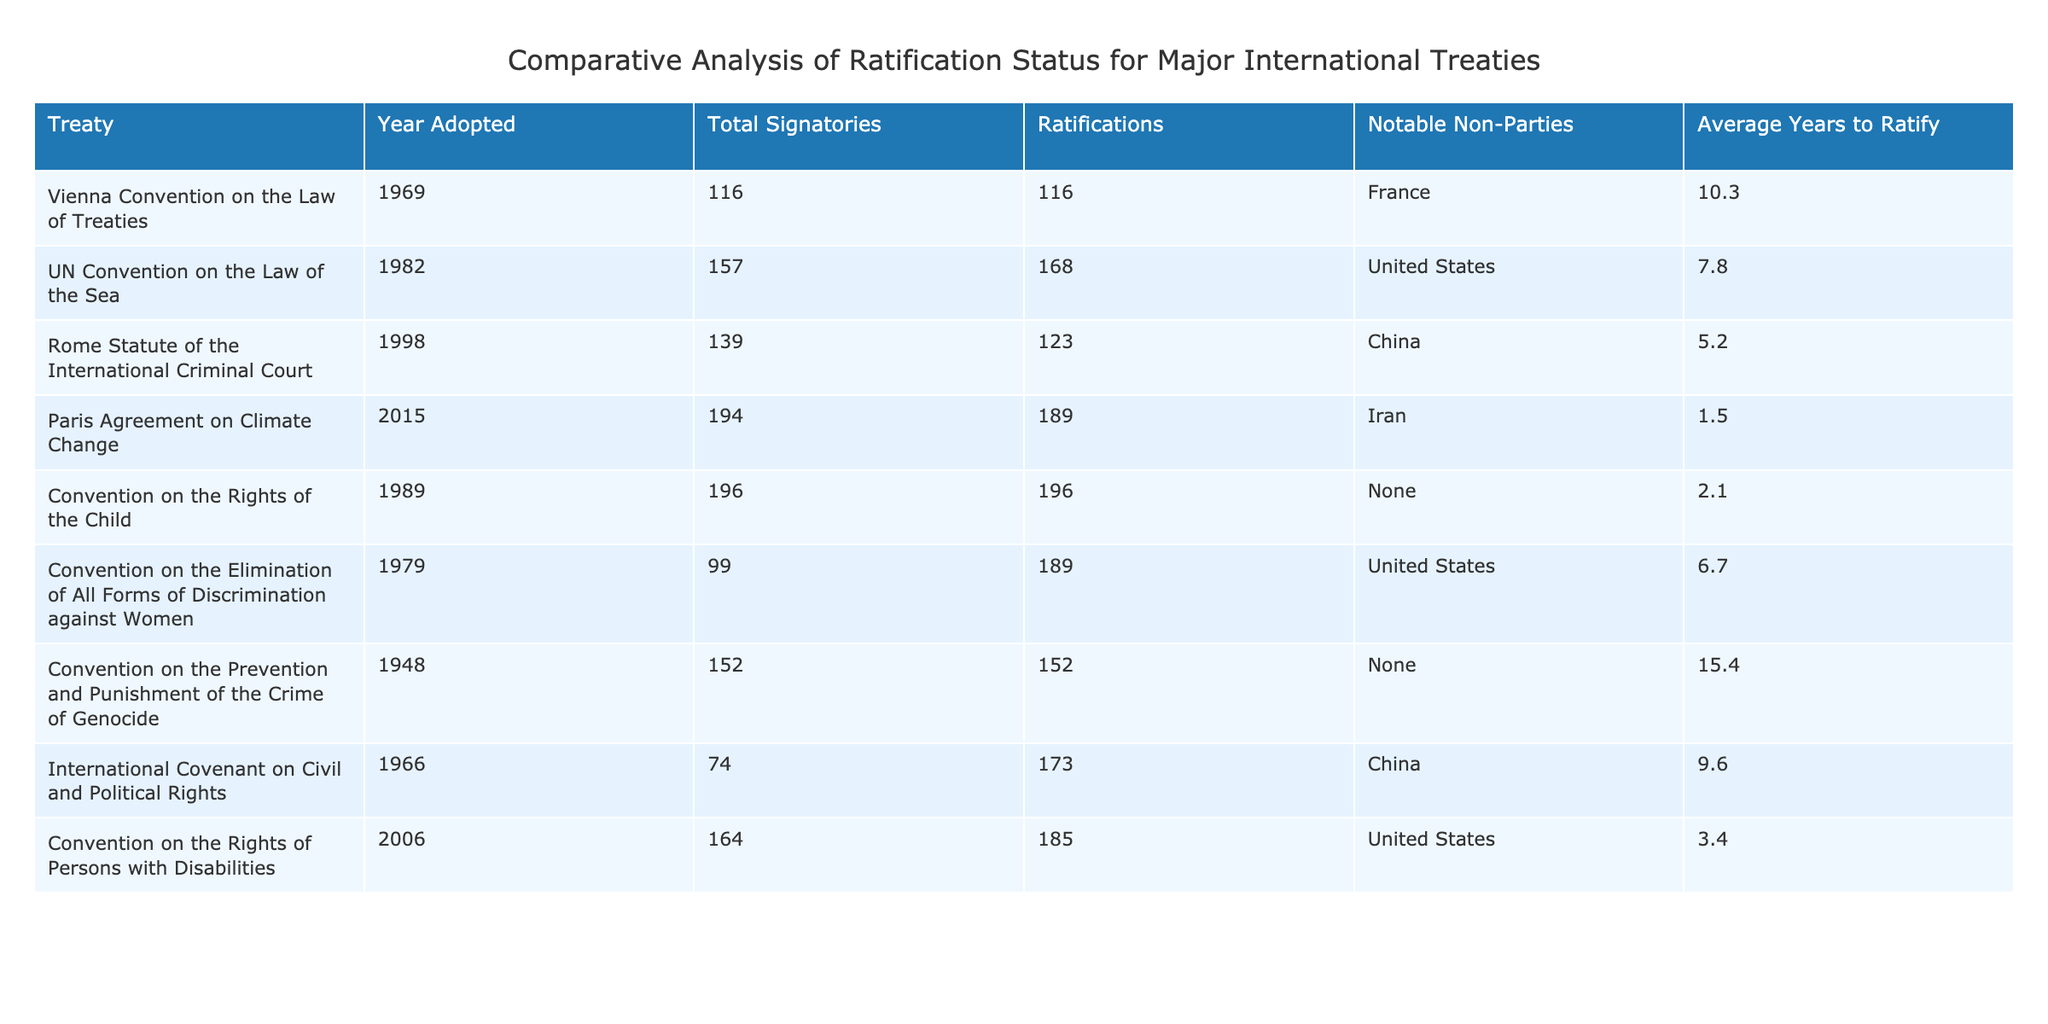What is the year in which the Rome Statute of the International Criminal Court was adopted? The table lists the year each treaty was adopted; for the Rome Statute, the corresponding year is 1998.
Answer: 1998 Which treaty has the highest number of ratifications? Looking at the "Ratifications" column, the International Covenant on Civil and Political Rights has 173 ratifications, which is the highest number compared to others.
Answer: International Covenant on Civil and Political Rights Is there any treaty that has no notable non-parties? The table indicates the notable non-parties for each treaty, and both the Convention on the Rights of the Child and the Convention on the Prevention and Punishment of the Crime of Genocide have "None" listed under notable non-parties.
Answer: Yes What is the average years to ratify for the UN Convention on the Law of the Sea and the Paris Agreement on Climate Change? The average years to ratify for the UN Convention on the Law of the Sea is 7.8 years, and for the Paris Agreement, it is 1.5 years. Adding these gives 7.8 + 1.5 = 9.3, and there are two treaties, so the average is 9.3 / 2 = 4.65 years.
Answer: 4.65 Which treaty has the lowest average years to ratify? The average years to ratify for each treaty can be checked. The Paris Agreement on Climate Change has the lowest average at 1.5 years.
Answer: Paris Agreement on Climate Change What is the difference in total signatories between the Convention on the Rights of the Child and the Convention on the Elimination of All Forms of Discrimination against Women? The total signatories for the Convention on the Rights of the Child is 196 and for the Convention on the Elimination of All Forms of Discrimination against Women is 99. The difference is 196 - 99 = 97.
Answer: 97 How many treaties have notable non-parties listed? By examining the "Notable Non-Parties" column, it can be seen that five treaties have notable non-parties, while four do not.
Answer: 5 Which treaty has the most total signatories, and what is that number? The total signatories column shows that the Convention on the Rights of the Child has 196 total signatories, which is the most among all listed treaties.
Answer: 196 Is Iran a notable non-party to the Paris Agreement on Climate Change? The "Notable Non-Parties" column for the Paris Agreement states that Iran is indeed a notable non-party.
Answer: Yes What is the total number of ratifications for the Vienna Convention on the Law of Treaties and the Convention on the Prevention and Punishment of the Crime of Genocide combined? The Vienna Convention has 116 ratifications and the Convention on the Prevention and Punishment of the Crime of Genocide has 152 ratifications. Adding these gives 116 + 152 = 268.
Answer: 268 Which treaty has notable non-parties? By reviewing the "Notable Non-Parties" column, it is clear that the Rome Statute of the International Criminal Court and the Convention on the Elimination of All Forms of Discrimination against Women both have notable non-parties listed, specifically China and the United States, respectively.
Answer: Yes 